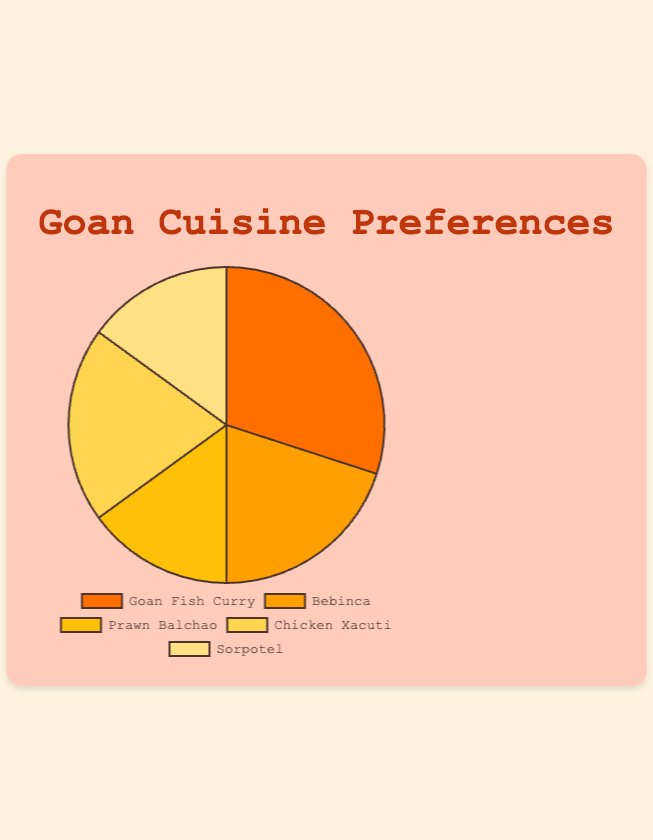What percentage of tourists enjoy Bebinca? Bebinca accounts for 20% of the tourists' preferences.
Answer: 20% Which Goan cuisine is the most popular among tourists? Goan Fish Curry has the highest percentage, at 30%.
Answer: Goan Fish Curry What is the combined percentage of tourists who enjoy Prawn Balchao and Sorpotel? Prawn Balchao is enjoyed by 15% of tourists and Sorpotel also by 15%. Adding these together: 15% + 15% = 30%.
Answer: 30% Which two Goan cuisines have the same percentage of tourists' preferences? Prawn Balchao and Sorpotel both have 15%.
Answer: Prawn Balchao and Sorpotel Is Chicken Xacuti more or less popular than Bebinca? Chicken Xacuti and Bebinca both have the same percentage, which is 20%.
Answer: Equal What is the least popular Goan cuisine enjoyed by tourists? The least popular are Prawn Balchao and Sorpotel, each with 15%.
Answer: Prawn Balchao and Sorpotel Calculate the average percentage of tourists who enjoy Chicken Xacuti and Goan Fish Curry. Chicken Xacuti is enjoyed by 20% and Goan Fish Curry by 30%. The average is (20% + 30%) / 2 = 25%.
Answer: 25% Which cuisine enjoyed by 20% of tourists is sweet? Bebinca, which is a sweet dish, is enjoyed by 20% of tourists.
Answer: Bebinca Compare the popularity of Goan Fish Curry to all other cuisines combined. Goan Fish Curry is 30%, and all other cuisines combined are: 20% (Bebinca) + 15% (Prawn Balchao) + 20% (Chicken Xacuti) + 15% (Sorpotel) = 70%. Goan Fish Curry is less popular compared to the sum of all other cuisines.
Answer: Less popular 